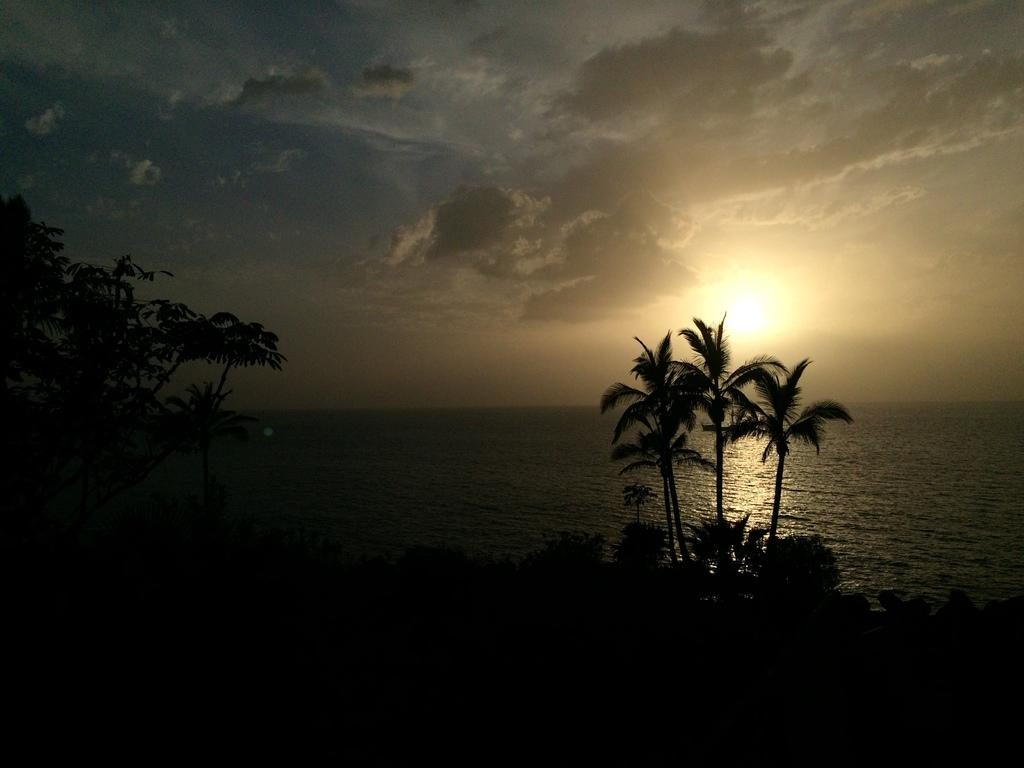What type of vegetation can be seen in the image? There are trees in the image. What natural element is visible in the image besides trees? There is water visible in the image. What part of the sky is visible in the image? The sky is present in the image, and clouds are visible. How would you describe the lighting in the image? The image appears to be a little dark. What type of ear is visible in the image? There is no ear present in the image. What type of plantation can be seen in the image? There is no plantation present in the image; it features trees and water. 